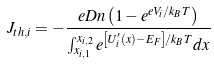<formula> <loc_0><loc_0><loc_500><loc_500>J _ { t h , i } = - \frac { e D n \left ( 1 - e ^ { e V _ { i } / k _ { B } T } \right ) } { \int _ { x _ { i , 1 } } ^ { x _ { i , 2 } } e ^ { \left [ U _ { i } ^ { \prime } ( x ) - E _ { F } \right ] / k _ { B } T } d x }</formula> 